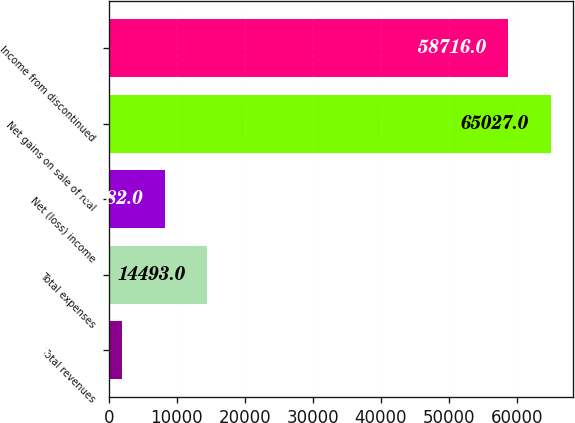Convert chart. <chart><loc_0><loc_0><loc_500><loc_500><bar_chart><fcel>Total revenues<fcel>Total expenses<fcel>Net (loss) income<fcel>Net gains on sale of real<fcel>Income from discontinued<nl><fcel>1871<fcel>14493<fcel>8182<fcel>65027<fcel>58716<nl></chart> 